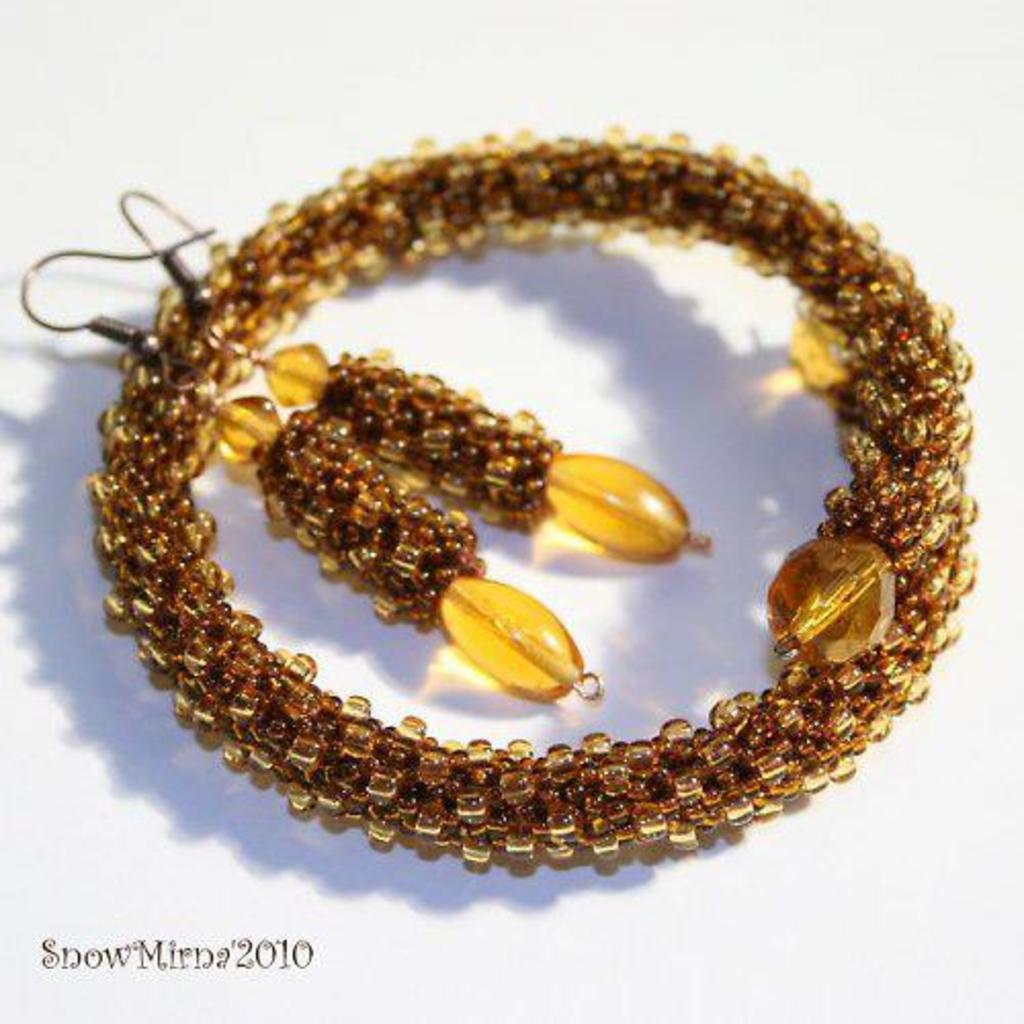What type of jewelry is visible in the image? There are earrings and a bracelet in the image. What is the color of the earrings and bracelet? The earrings and bracelet are brown in color. What is the color of the background in the image? The background of the image is white. How does the coastline affect the throat of the person wearing the earrings in the image? There is no coastline or person visible in the image, so it is not possible to determine any effect on the throat. 